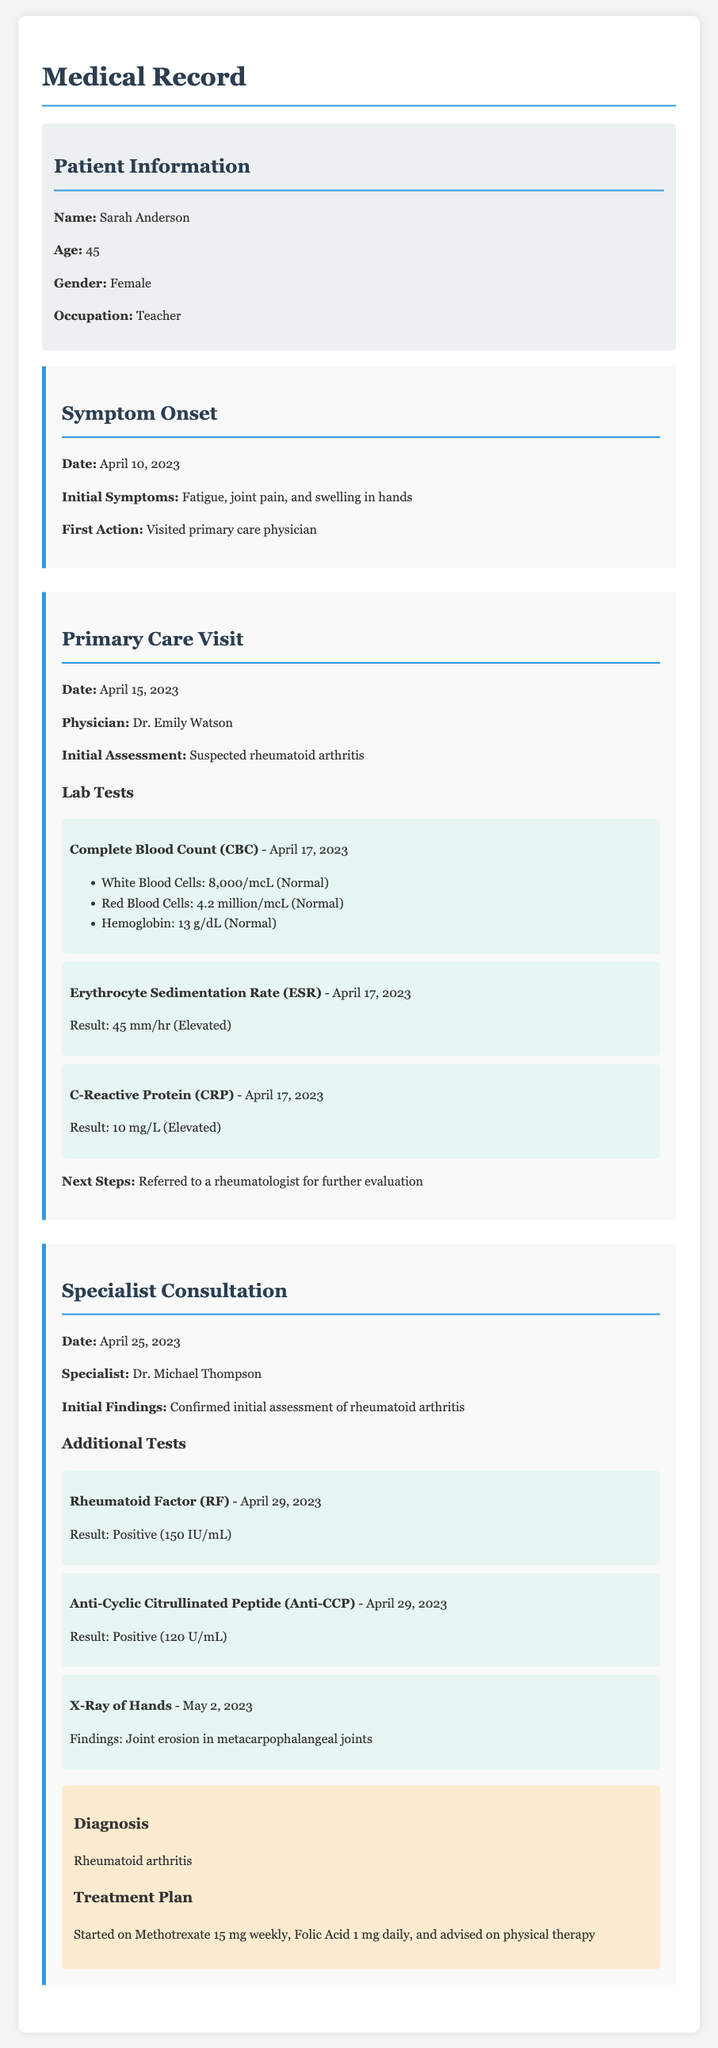What are the initial symptoms reported by the patient? The initial symptoms reported by the patient are fatigue, joint pain, and swelling in hands.
Answer: Fatigue, joint pain, and swelling in hands Who was the primary care physician? The primary care physician is mentioned as Dr. Emily Watson.
Answer: Dr. Emily Watson What was the result of the Erythrocyte Sedimentation Rate test? The Erythrocyte Sedimentation Rate test result is 45 mm/hr, which is elevated.
Answer: 45 mm/hr (Elevated) What was the date of the specialist consultation? The date of the specialist consultation is April 25, 2023.
Answer: April 25, 2023 What diagnosis was confirmed during the specialist consultation? The diagnosis confirmed was rheumatoid arthritis.
Answer: Rheumatoid arthritis What treatment plan was initiated for the patient? The treatment plan started includes Methotrexate 15 mg weekly, Folic Acid 1 mg daily, and advised physical therapy.
Answer: Methotrexate 15 mg weekly, Folic Acid 1 mg daily, and advised physical therapy 